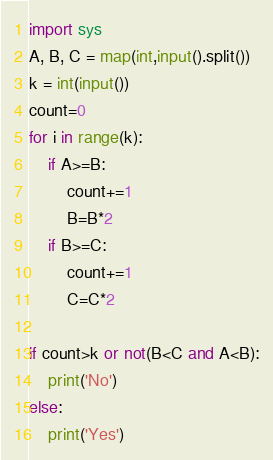<code> <loc_0><loc_0><loc_500><loc_500><_Python_>import sys
A, B, C = map(int,input().split())
k = int(input())
count=0
for i in range(k):
    if A>=B:
        count+=1
        B=B*2
    if B>=C:
        count+=1
        C=C*2

if count>k or not(B<C and A<B):
    print('No')
else:
    print('Yes')</code> 